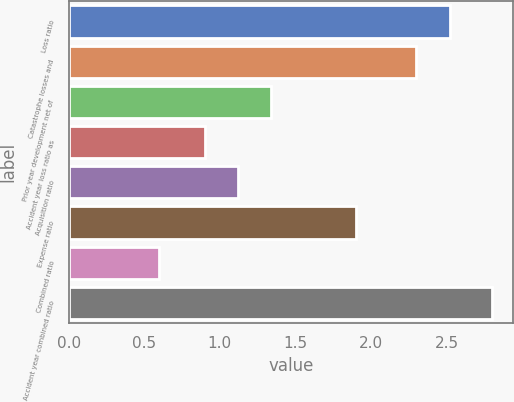<chart> <loc_0><loc_0><loc_500><loc_500><bar_chart><fcel>Loss ratio<fcel>Catastrophe losses and<fcel>Prior year development net of<fcel>Accident year loss ratio as<fcel>Acquisition ratio<fcel>Expense ratio<fcel>Combined ratio<fcel>Accident year combined ratio<nl><fcel>2.52<fcel>2.3<fcel>1.34<fcel>0.9<fcel>1.12<fcel>1.9<fcel>0.6<fcel>2.8<nl></chart> 